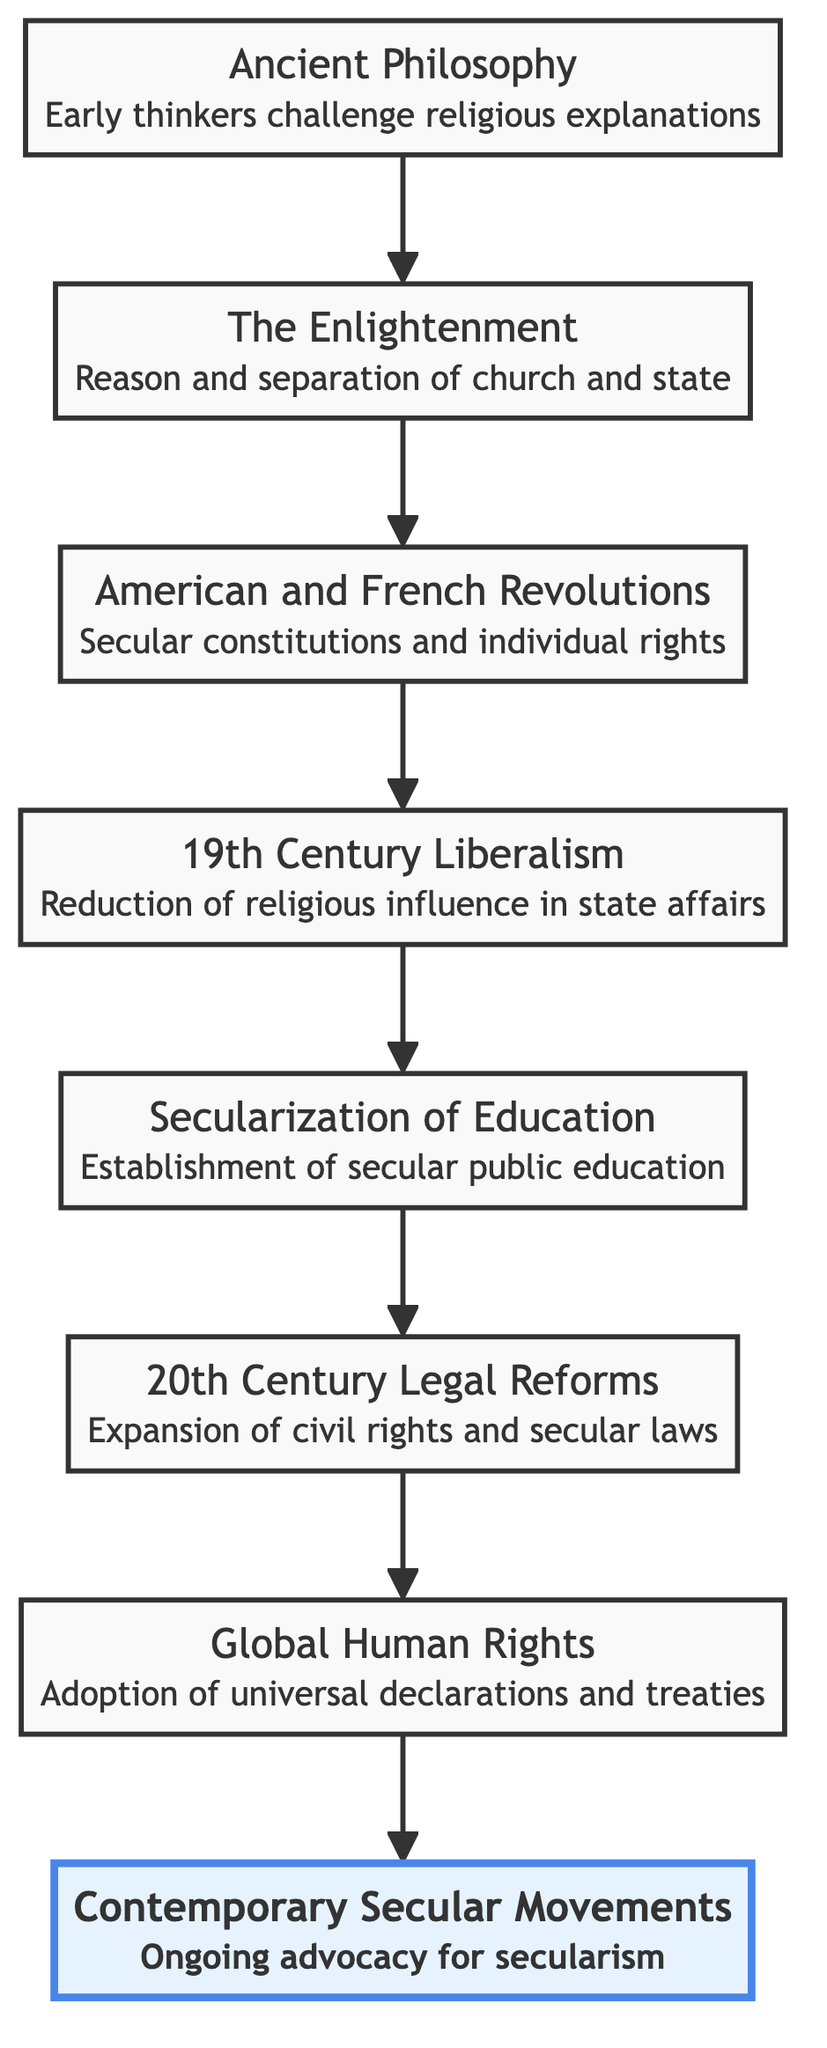What is the first element in the diagram? The first element in the diagram is at the bottom, which is "Ancient Philosophy." It’s the initial point of the flow, representing the beginning of the evolution of secular governance.
Answer: Ancient Philosophy How many total nodes are there in the diagram? Counting each distinct element in the flow chart, there are eight nodes present, each representing a stage in the evolution of secular governance.
Answer: 8 What element follows "19th Century Liberalism" in the flow? The element that follows "19th Century Liberalism" in the flow is "Secularization of Education." This indicates a progression from liberal political movements towards educational reforms.
Answer: Secularization of Education Which two elements are connected by a direct edge? "The Enlightenment" and "American and French Revolutions" are connected by a direct edge, showing the influence of Enlightenment ideas on the revolutions.
Answer: The Enlightenment and American and French Revolutions What does “Global Human Rights” emphasize in the context of the diagram? “Global Human Rights” emphasizes the adoption of universal declarations and treaties that foster secular legal frameworks at an international level. This shows a culmination of previous developments leading to a global perspective.
Answer: Adoption of universal declarations and treaties Which element represents ongoing advocacy for secularism? The element representing ongoing advocacy for secularism is "Contemporary Secular Movements." It signifies the continuing effort to challenge religious influence in governance.
Answer: Contemporary Secular Movements What is the last element in the flow chart? The last element in the flow chart is "Contemporary Secular Movements," which represents the most recent phase in the evolution of secular governance.
Answer: Contemporary Secular Movements Explain how many elements significantly focus on legal reforms. There are two significant elements focusing on legal reforms: "20th Century Legal Reforms" and "Global Human Rights." Together, they illustrate the historical process of advancing civil rights and establishing legal frameworks that support secular governance.
Answer: 2 What element serves as a transition between philosophical ideas and practical governance? The element that serves as a transition between philosophical ideas from "The Enlightenment" to practical governance is "American and French Revolutions." This indicates how Enlightenment principles were implemented in actual governments.
Answer: American and French Revolutions 